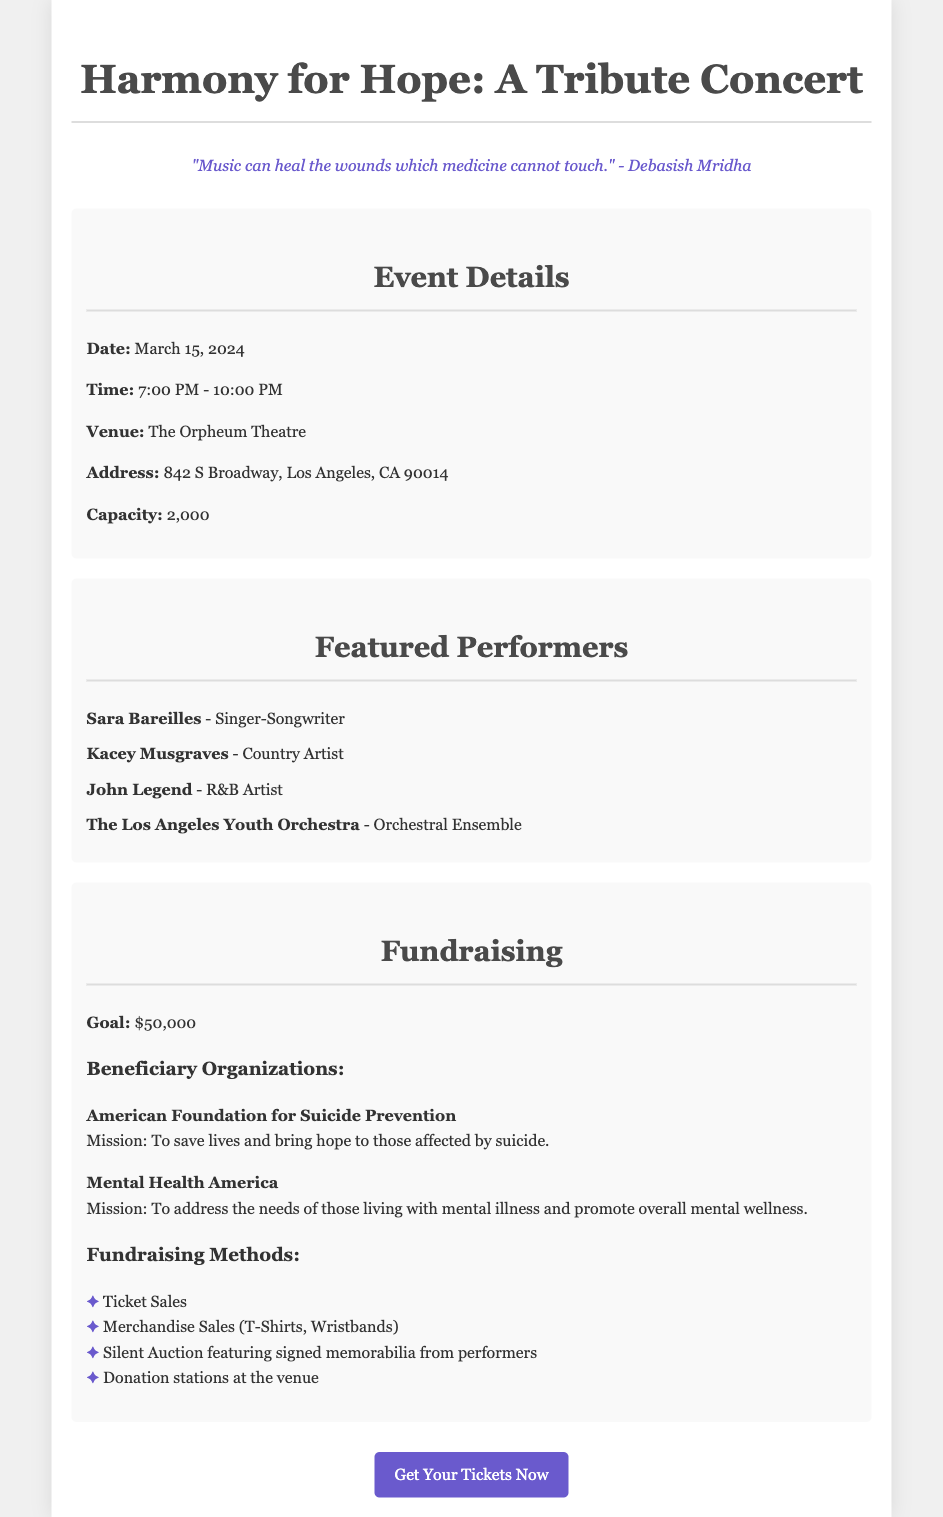What is the date of the tribute concert? The date of the tribute concert is explicitly mentioned in the document as March 15, 2024.
Answer: March 15, 2024 What is the venue of the concert? The venue where the concert will take place is specified as The Orpheum Theatre.
Answer: The Orpheum Theatre How many performers are listed in the document? The document lists four featured performers, which indicates the number of performers at the concert.
Answer: 4 What is the fundraising goal for the concert? The document clearly states that the goal is set at $50,000 for the concert.
Answer: $50,000 What are the names of the beneficiary organizations? The document provides two beneficiary organizations: the American Foundation for Suicide Prevention and Mental Health America.
Answer: American Foundation for Suicide Prevention, Mental Health America What time does the concert start? The starting time for the concert is provided in the document as 7:00 PM.
Answer: 7:00 PM What type of merchandise will be sold at the concert? The document mentions that T-Shirts and Wristbands will be sold as merchandise at the concert.
Answer: T-Shirts, Wristbands What item is part of the silent auction? The document notes that signed memorabilia from performers will be featured in the silent auction.
Answer: Signed memorabilia from performers 